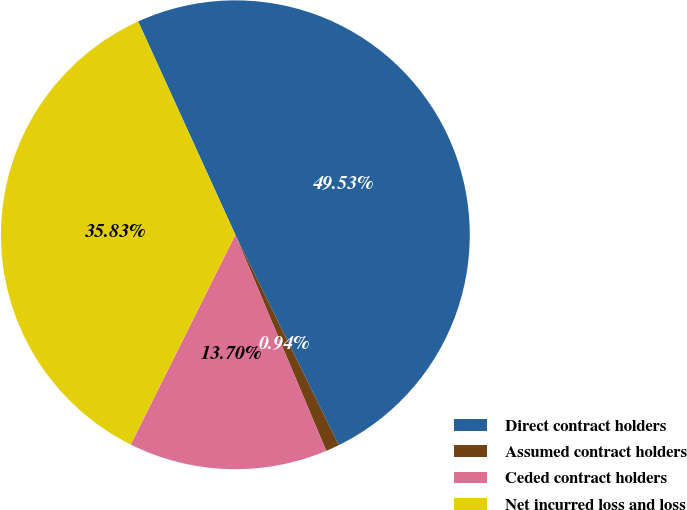<chart> <loc_0><loc_0><loc_500><loc_500><pie_chart><fcel>Direct contract holders<fcel>Assumed contract holders<fcel>Ceded contract holders<fcel>Net incurred loss and loss<nl><fcel>49.53%<fcel>0.94%<fcel>13.7%<fcel>35.83%<nl></chart> 